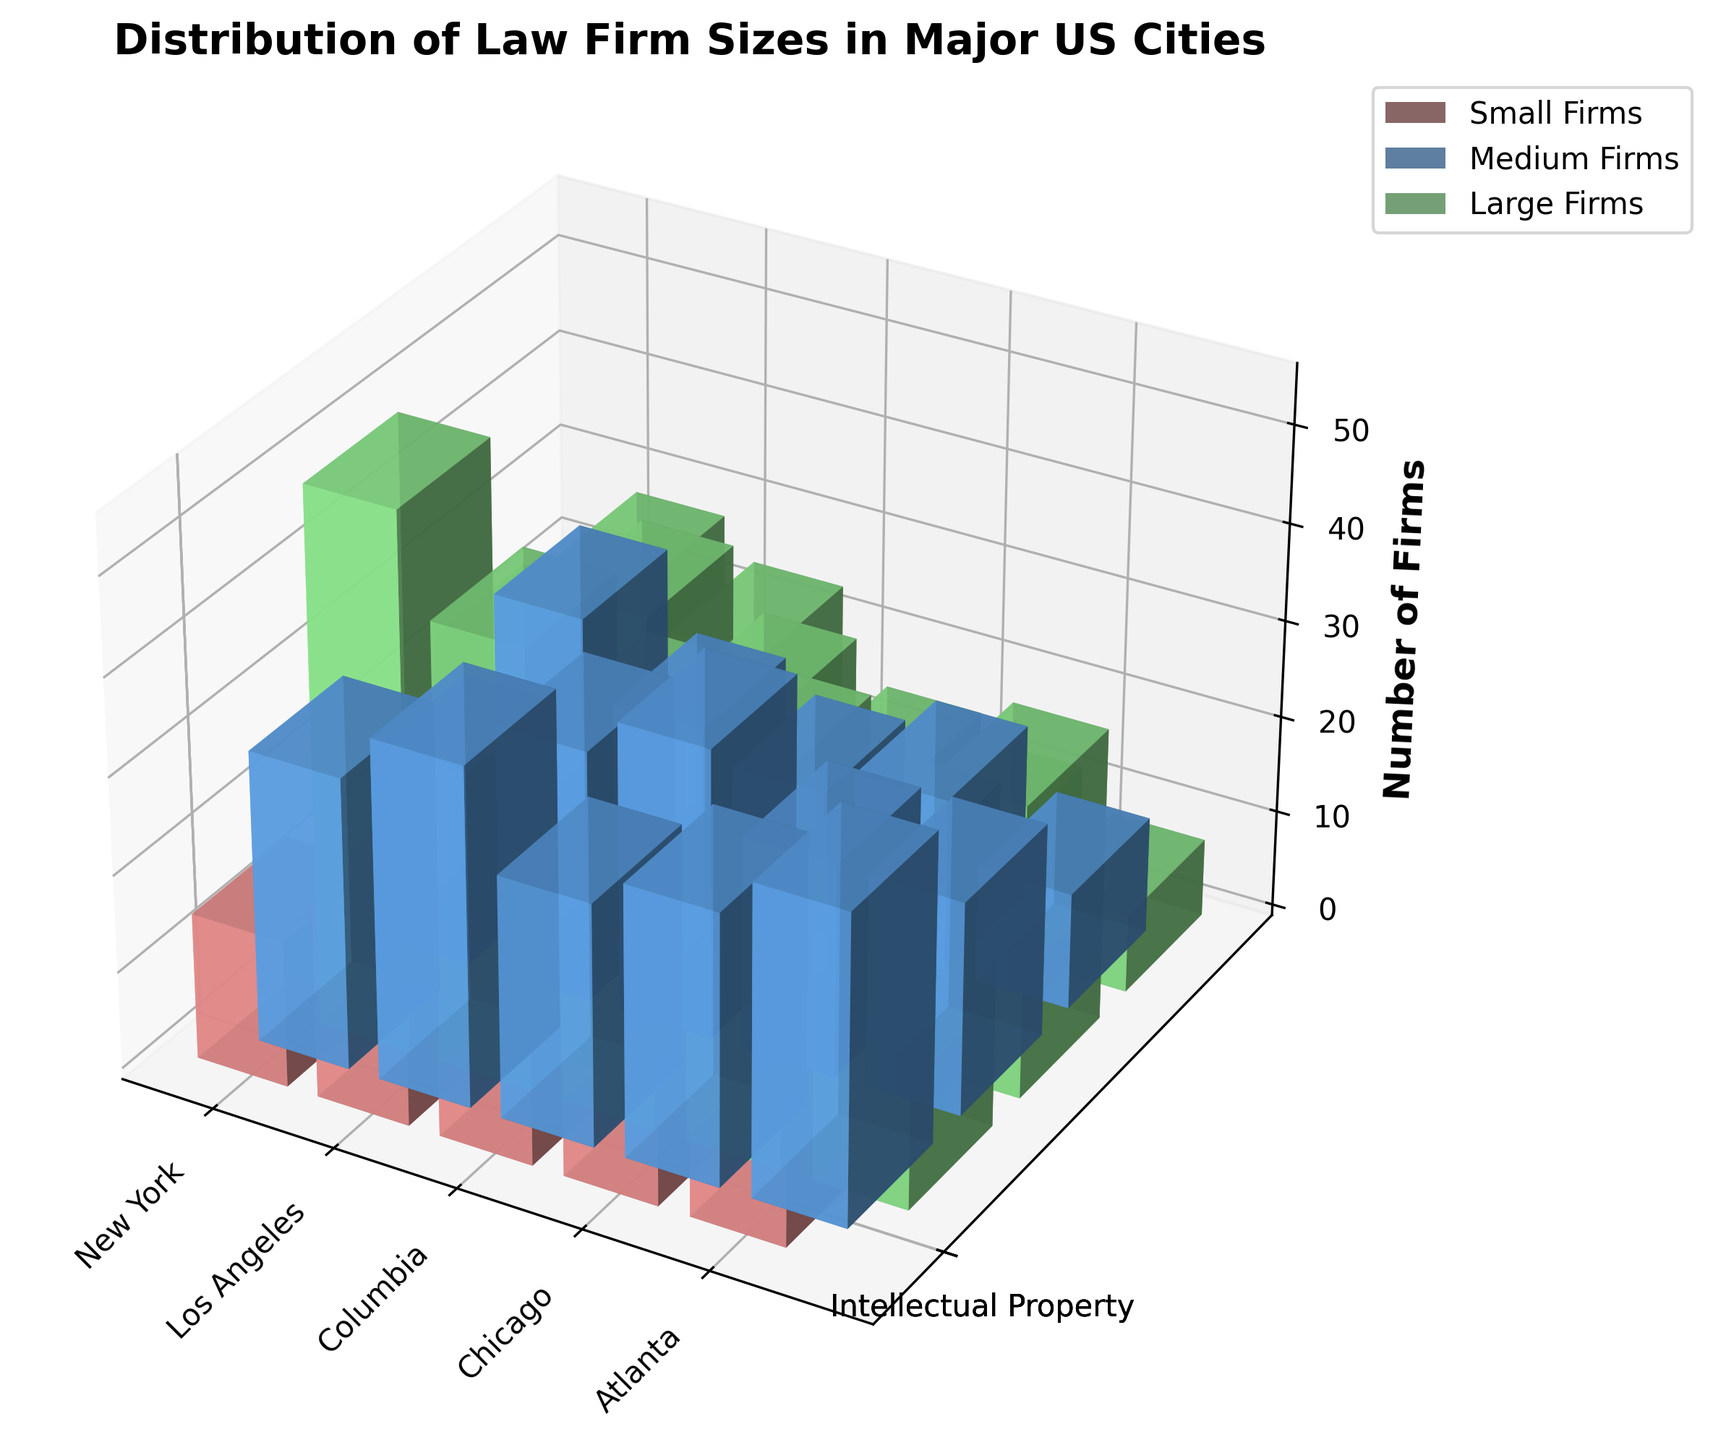What is the title of the figure? The title of the figure is typically located at the top of the plot. By reading this area, we can identify the title.
Answer: Distribution of Law Firm Sizes in Major US Cities How many colors are used to represent the different firm sizes? By visually inspecting the bars in the plot, we can count the distinct colors used.
Answer: 3 Which city has the highest number of large firms in the Corporate practice area? By locating the bars representing large firms and checking their heights in each city's Corporate practice area, we can identify the highest one.
Answer: New York How many medium-sized firms are there in Litigation practice areas across all cities? We need to sum up the bars corresponding to medium-sized firms in the Litigation practice area for each city. (35+32+30+26+18)
Answer: 141 Ordering by the number of small firms in the Intellectual Property practice area, which city comes first and last? Comparing the heights of the small firm bars in the Intellectual Property practice area for each city, we can figure out the minimum and maximum values.
Answer: First: New York, Last: Columbia In which city do the Corporate practice areas show the smallest variation in firm sizes? We need to compare the difference between the highest and lowest bars for Corporate practice areas in each city.
Answer: Columbia Between Chicago and Los Angeles, which city has more large firms in the Litigation practice area? Comparing the heights of the large firm bars for the Litigation practice area in each of these two cities, we can identify the larger one.
Answer: Chicago Which practice area in Atlanta has the lowest number of small firms? Checking the heights of the small firm bars for each practice area in Atlanta, we can find the smallest one.
Answer: Intellectual Property Is the number of medium firms in the Corporate practice area greater in New York or Chicago? By comparing the heights of the medium firm bars for the Corporate practice area in these two cities, we can determine the larger one.
Answer: New York What is the average number of small firms in all practice areas in Columbia? Summing the numbers of small firms in Columbia for all practice areas and dividing by the count of practice areas (8+10+5)/3
Answer: 7.7 